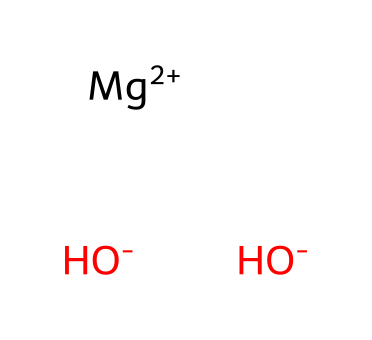What is the main component of milk of magnesia? The SMILES representation indicates that magnesium hydroxide, represented by [Mg+2] and [OH-] groups, is the primary active ingredient in milk of magnesia.
Answer: magnesium hydroxide How many hydroxide ions are present in the chemical structure? The SMILES indicates two [OH-] groups are attached to the magnesium ion, indicating there are two hydroxide ions in the structure.
Answer: two What charge does the magnesium ion have? The SMILES shows the magnesium ion as [Mg+2], indicating a +2 charge on the magnesium ion.
Answer: +2 What type of chemical compound is magnesium hydroxide? Magnesium hydroxide, having both metal (magnesium) and hydroxide groups, classifies it as a base due to the presence of hydroxide ions.
Answer: base How many atoms are in total in magnesium hydroxide? Analyzing the SMILES notation: 1 magnesium atom (Mg), 2 oxygen atoms (from two OH- groups), and 2 hydrogen atoms (from two OH- groups), resulting in a total of 5 atoms.
Answer: five 